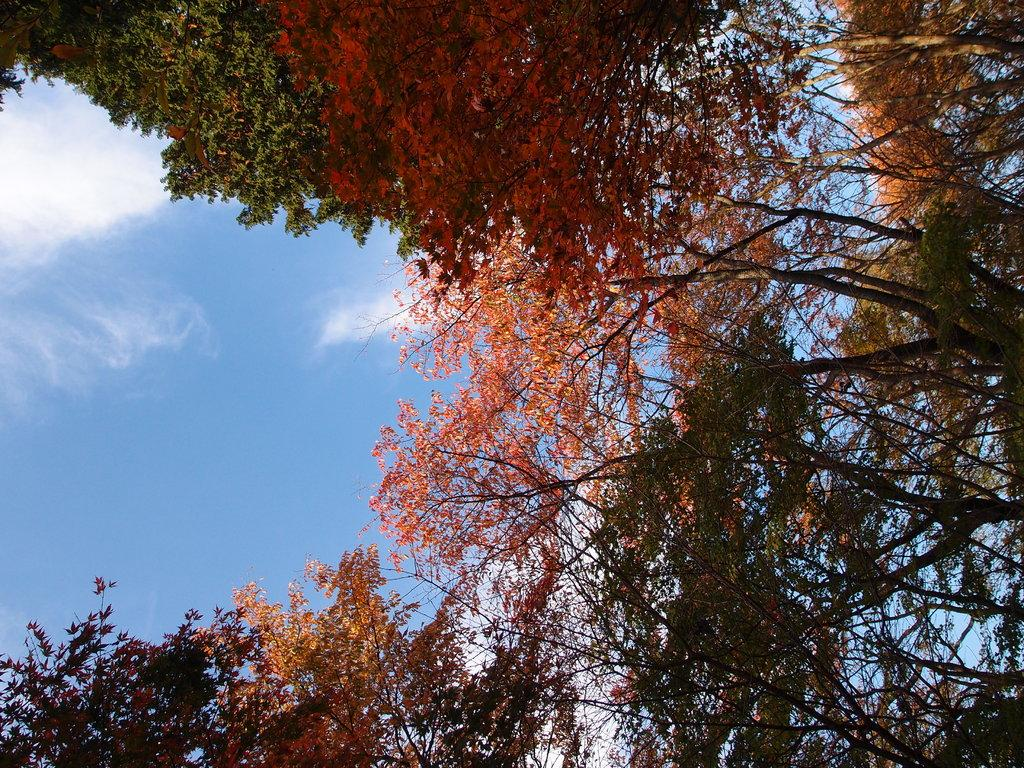What type of vegetation can be seen in the image? There are trees in the image. What part of the natural environment is visible in the image? The sky is visible in the image. What can be seen in the sky in the image? Clouds are present in the sky. How many tin boats are floating in the sky in the image? There are no tin boats present in the image; the image only features trees and clouds in the sky. 